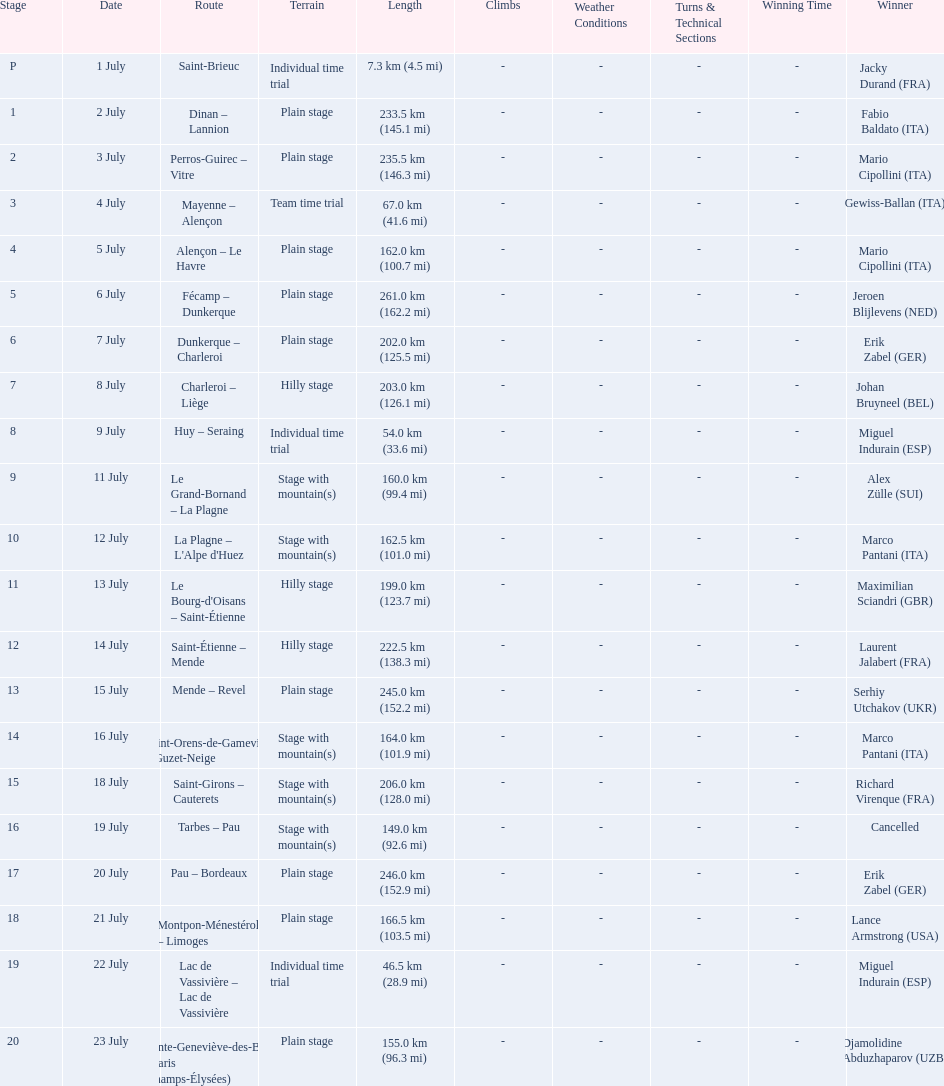How many routes have below 100 km total? 4. 